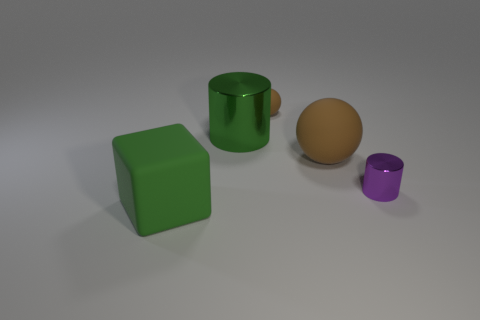How many brown balls must be subtracted to get 1 brown balls? 1 Subtract 0 gray cylinders. How many objects are left? 5 Subtract all cylinders. How many objects are left? 3 Subtract 1 cylinders. How many cylinders are left? 1 Subtract all cyan cubes. Subtract all brown spheres. How many cubes are left? 1 Subtract all cyan spheres. How many purple cylinders are left? 1 Subtract all balls. Subtract all large shiny things. How many objects are left? 2 Add 3 big brown matte things. How many big brown matte things are left? 4 Add 4 large cubes. How many large cubes exist? 5 Add 1 tiny brown metallic balls. How many objects exist? 6 